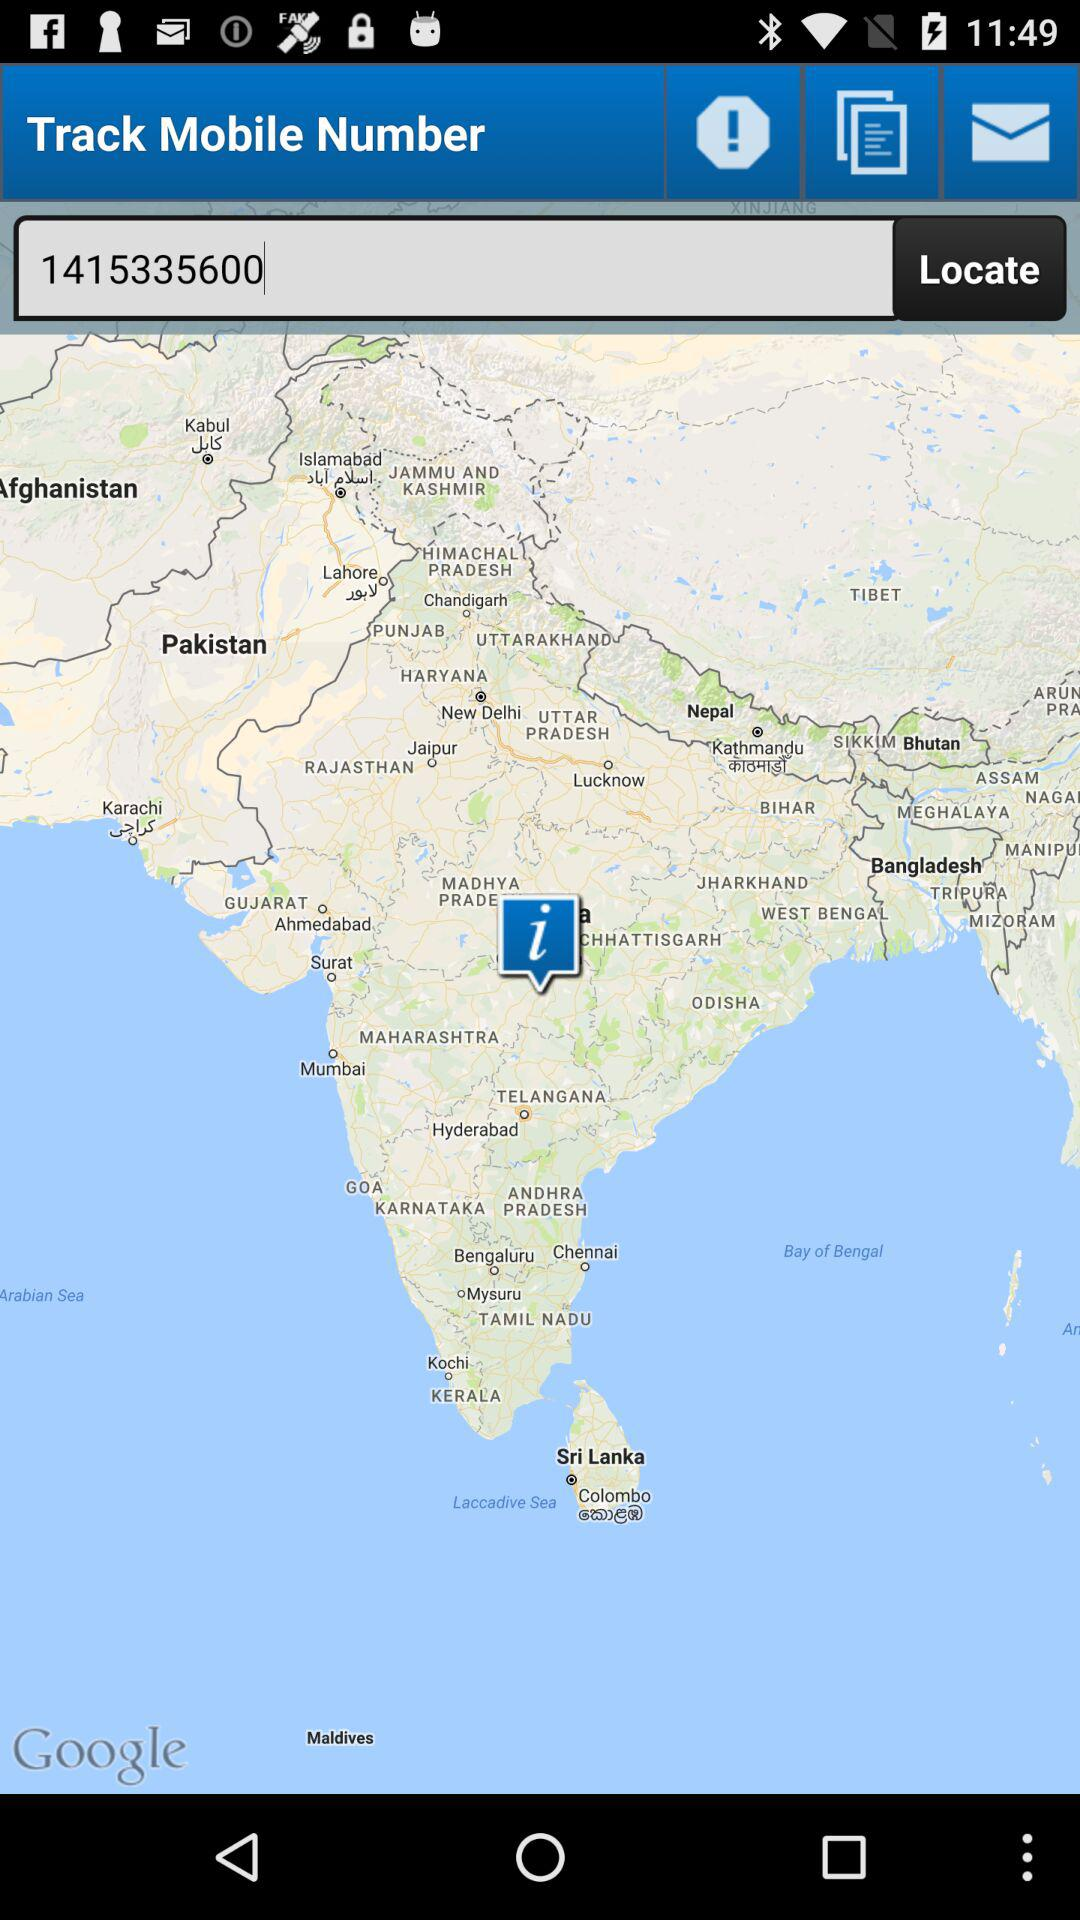What is the phone number to track? The phone number is 1415335600. 